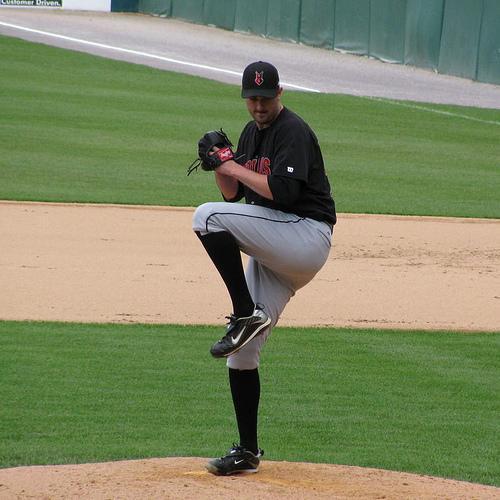How many people are shown?
Give a very brief answer. 1. How many vases have flowers in them?
Give a very brief answer. 0. 